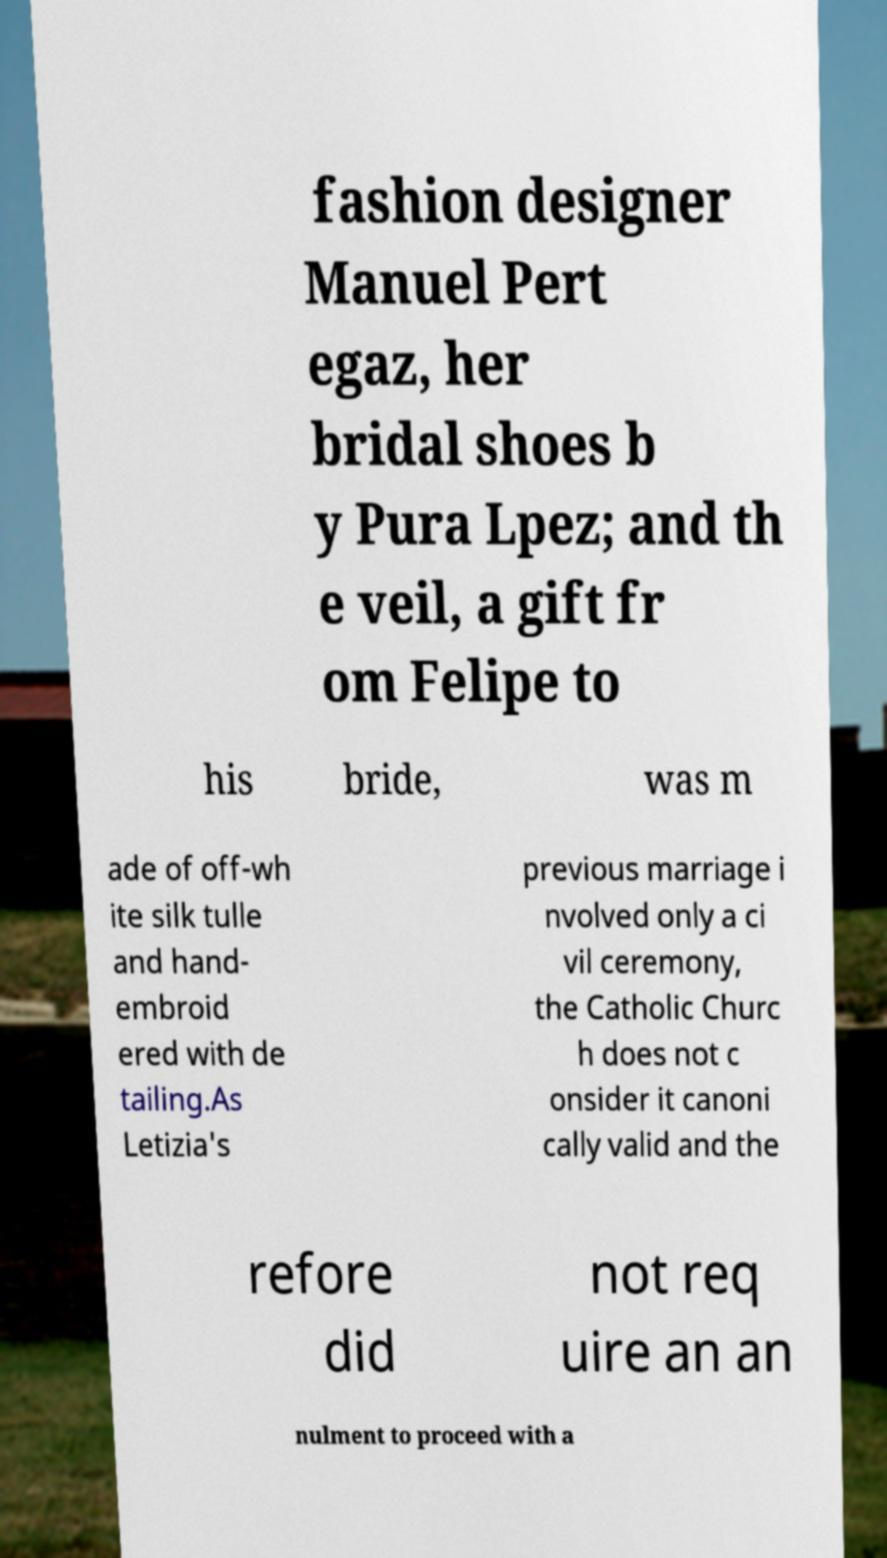Can you accurately transcribe the text from the provided image for me? fashion designer Manuel Pert egaz, her bridal shoes b y Pura Lpez; and th e veil, a gift fr om Felipe to his bride, was m ade of off-wh ite silk tulle and hand- embroid ered with de tailing.As Letizia's previous marriage i nvolved only a ci vil ceremony, the Catholic Churc h does not c onsider it canoni cally valid and the refore did not req uire an an nulment to proceed with a 